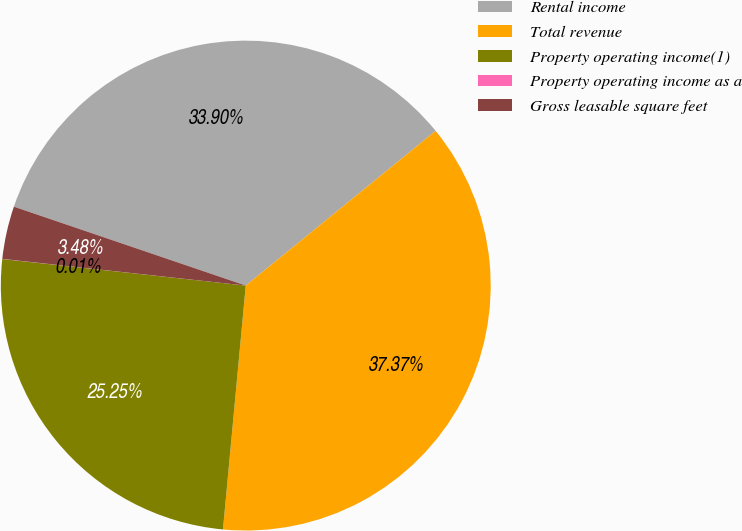Convert chart to OTSL. <chart><loc_0><loc_0><loc_500><loc_500><pie_chart><fcel>Rental income<fcel>Total revenue<fcel>Property operating income(1)<fcel>Property operating income as a<fcel>Gross leasable square feet<nl><fcel>33.9%<fcel>37.37%<fcel>25.25%<fcel>0.01%<fcel>3.48%<nl></chart> 